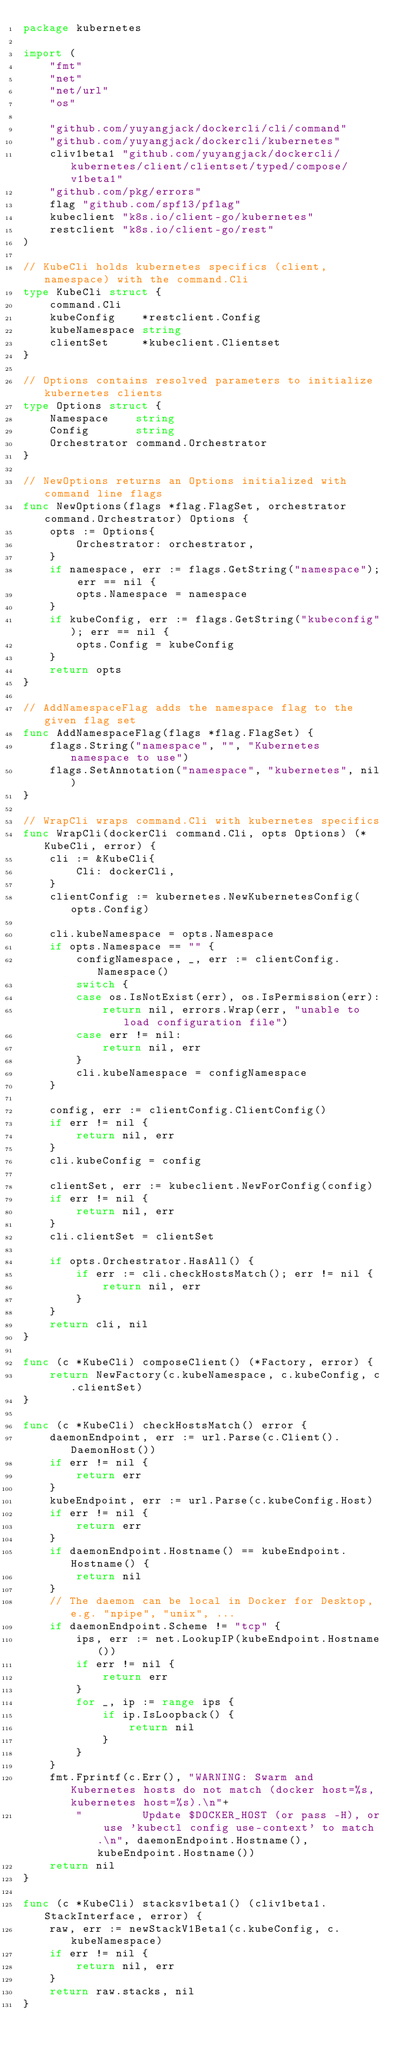Convert code to text. <code><loc_0><loc_0><loc_500><loc_500><_Go_>package kubernetes

import (
	"fmt"
	"net"
	"net/url"
	"os"

	"github.com/yuyangjack/dockercli/cli/command"
	"github.com/yuyangjack/dockercli/kubernetes"
	cliv1beta1 "github.com/yuyangjack/dockercli/kubernetes/client/clientset/typed/compose/v1beta1"
	"github.com/pkg/errors"
	flag "github.com/spf13/pflag"
	kubeclient "k8s.io/client-go/kubernetes"
	restclient "k8s.io/client-go/rest"
)

// KubeCli holds kubernetes specifics (client, namespace) with the command.Cli
type KubeCli struct {
	command.Cli
	kubeConfig    *restclient.Config
	kubeNamespace string
	clientSet     *kubeclient.Clientset
}

// Options contains resolved parameters to initialize kubernetes clients
type Options struct {
	Namespace    string
	Config       string
	Orchestrator command.Orchestrator
}

// NewOptions returns an Options initialized with command line flags
func NewOptions(flags *flag.FlagSet, orchestrator command.Orchestrator) Options {
	opts := Options{
		Orchestrator: orchestrator,
	}
	if namespace, err := flags.GetString("namespace"); err == nil {
		opts.Namespace = namespace
	}
	if kubeConfig, err := flags.GetString("kubeconfig"); err == nil {
		opts.Config = kubeConfig
	}
	return opts
}

// AddNamespaceFlag adds the namespace flag to the given flag set
func AddNamespaceFlag(flags *flag.FlagSet) {
	flags.String("namespace", "", "Kubernetes namespace to use")
	flags.SetAnnotation("namespace", "kubernetes", nil)
}

// WrapCli wraps command.Cli with kubernetes specifics
func WrapCli(dockerCli command.Cli, opts Options) (*KubeCli, error) {
	cli := &KubeCli{
		Cli: dockerCli,
	}
	clientConfig := kubernetes.NewKubernetesConfig(opts.Config)

	cli.kubeNamespace = opts.Namespace
	if opts.Namespace == "" {
		configNamespace, _, err := clientConfig.Namespace()
		switch {
		case os.IsNotExist(err), os.IsPermission(err):
			return nil, errors.Wrap(err, "unable to load configuration file")
		case err != nil:
			return nil, err
		}
		cli.kubeNamespace = configNamespace
	}

	config, err := clientConfig.ClientConfig()
	if err != nil {
		return nil, err
	}
	cli.kubeConfig = config

	clientSet, err := kubeclient.NewForConfig(config)
	if err != nil {
		return nil, err
	}
	cli.clientSet = clientSet

	if opts.Orchestrator.HasAll() {
		if err := cli.checkHostsMatch(); err != nil {
			return nil, err
		}
	}
	return cli, nil
}

func (c *KubeCli) composeClient() (*Factory, error) {
	return NewFactory(c.kubeNamespace, c.kubeConfig, c.clientSet)
}

func (c *KubeCli) checkHostsMatch() error {
	daemonEndpoint, err := url.Parse(c.Client().DaemonHost())
	if err != nil {
		return err
	}
	kubeEndpoint, err := url.Parse(c.kubeConfig.Host)
	if err != nil {
		return err
	}
	if daemonEndpoint.Hostname() == kubeEndpoint.Hostname() {
		return nil
	}
	// The daemon can be local in Docker for Desktop, e.g. "npipe", "unix", ...
	if daemonEndpoint.Scheme != "tcp" {
		ips, err := net.LookupIP(kubeEndpoint.Hostname())
		if err != nil {
			return err
		}
		for _, ip := range ips {
			if ip.IsLoopback() {
				return nil
			}
		}
	}
	fmt.Fprintf(c.Err(), "WARNING: Swarm and Kubernetes hosts do not match (docker host=%s, kubernetes host=%s).\n"+
		"         Update $DOCKER_HOST (or pass -H), or use 'kubectl config use-context' to match.\n", daemonEndpoint.Hostname(), kubeEndpoint.Hostname())
	return nil
}

func (c *KubeCli) stacksv1beta1() (cliv1beta1.StackInterface, error) {
	raw, err := newStackV1Beta1(c.kubeConfig, c.kubeNamespace)
	if err != nil {
		return nil, err
	}
	return raw.stacks, nil
}
</code> 